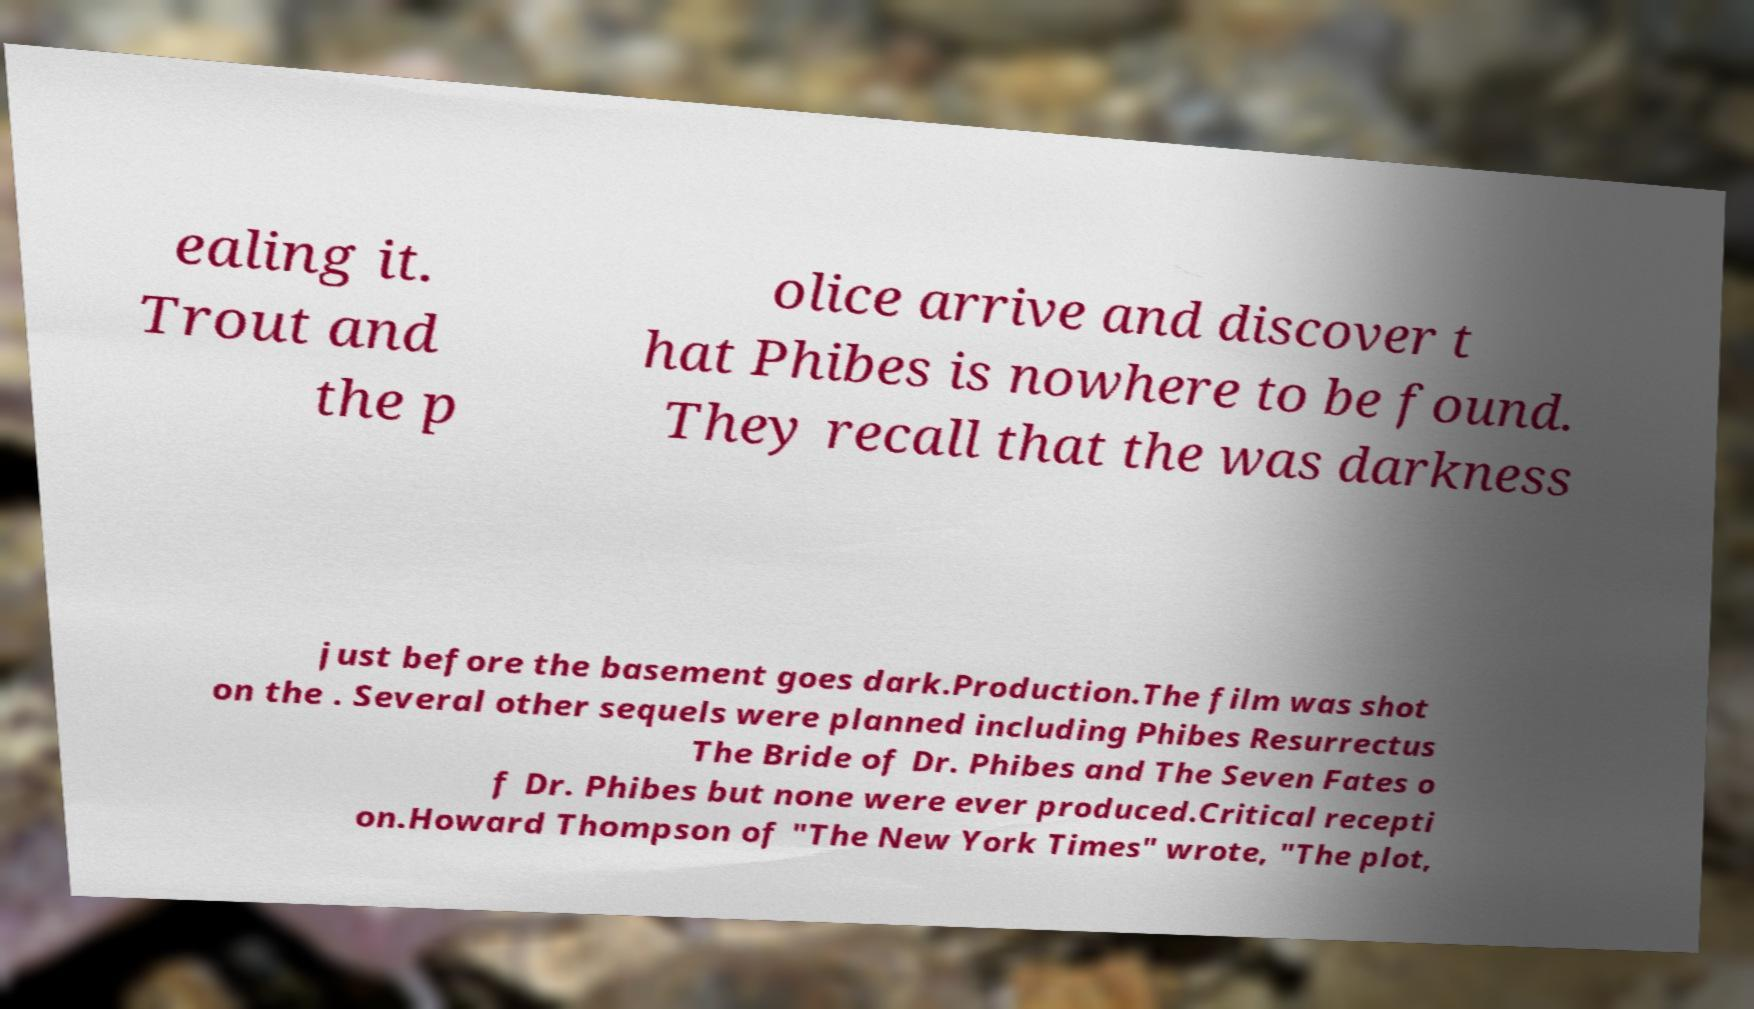Could you extract and type out the text from this image? ealing it. Trout and the p olice arrive and discover t hat Phibes is nowhere to be found. They recall that the was darkness just before the basement goes dark.Production.The film was shot on the . Several other sequels were planned including Phibes Resurrectus The Bride of Dr. Phibes and The Seven Fates o f Dr. Phibes but none were ever produced.Critical recepti on.Howard Thompson of "The New York Times" wrote, "The plot, 